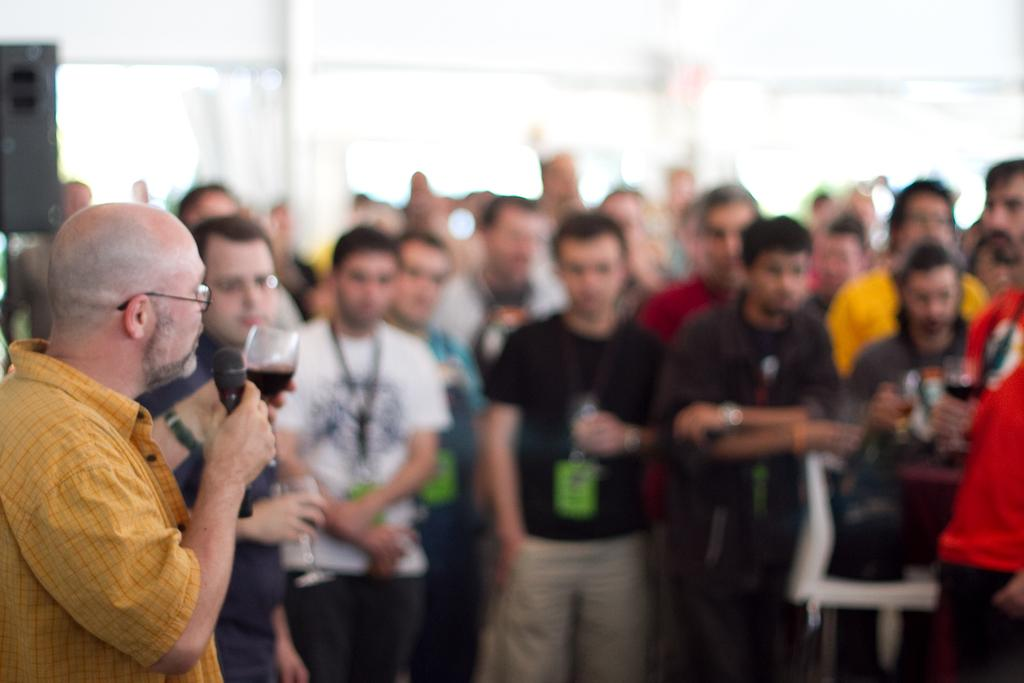What are the people in the image doing? The people in the image are standing in the center. Can you describe the man on the left side of the image? The man on the left is holding a mic and a wine glass in his hands. What can be seen in the background of the image? There is a wall in the background of the image. Can you see any berries being shared between the people in the image? There are no berries present in the image. Is there a knife visible in the man's hand as he holds the mic? No, the man is holding a wine glass, not a knife, in his hand. 